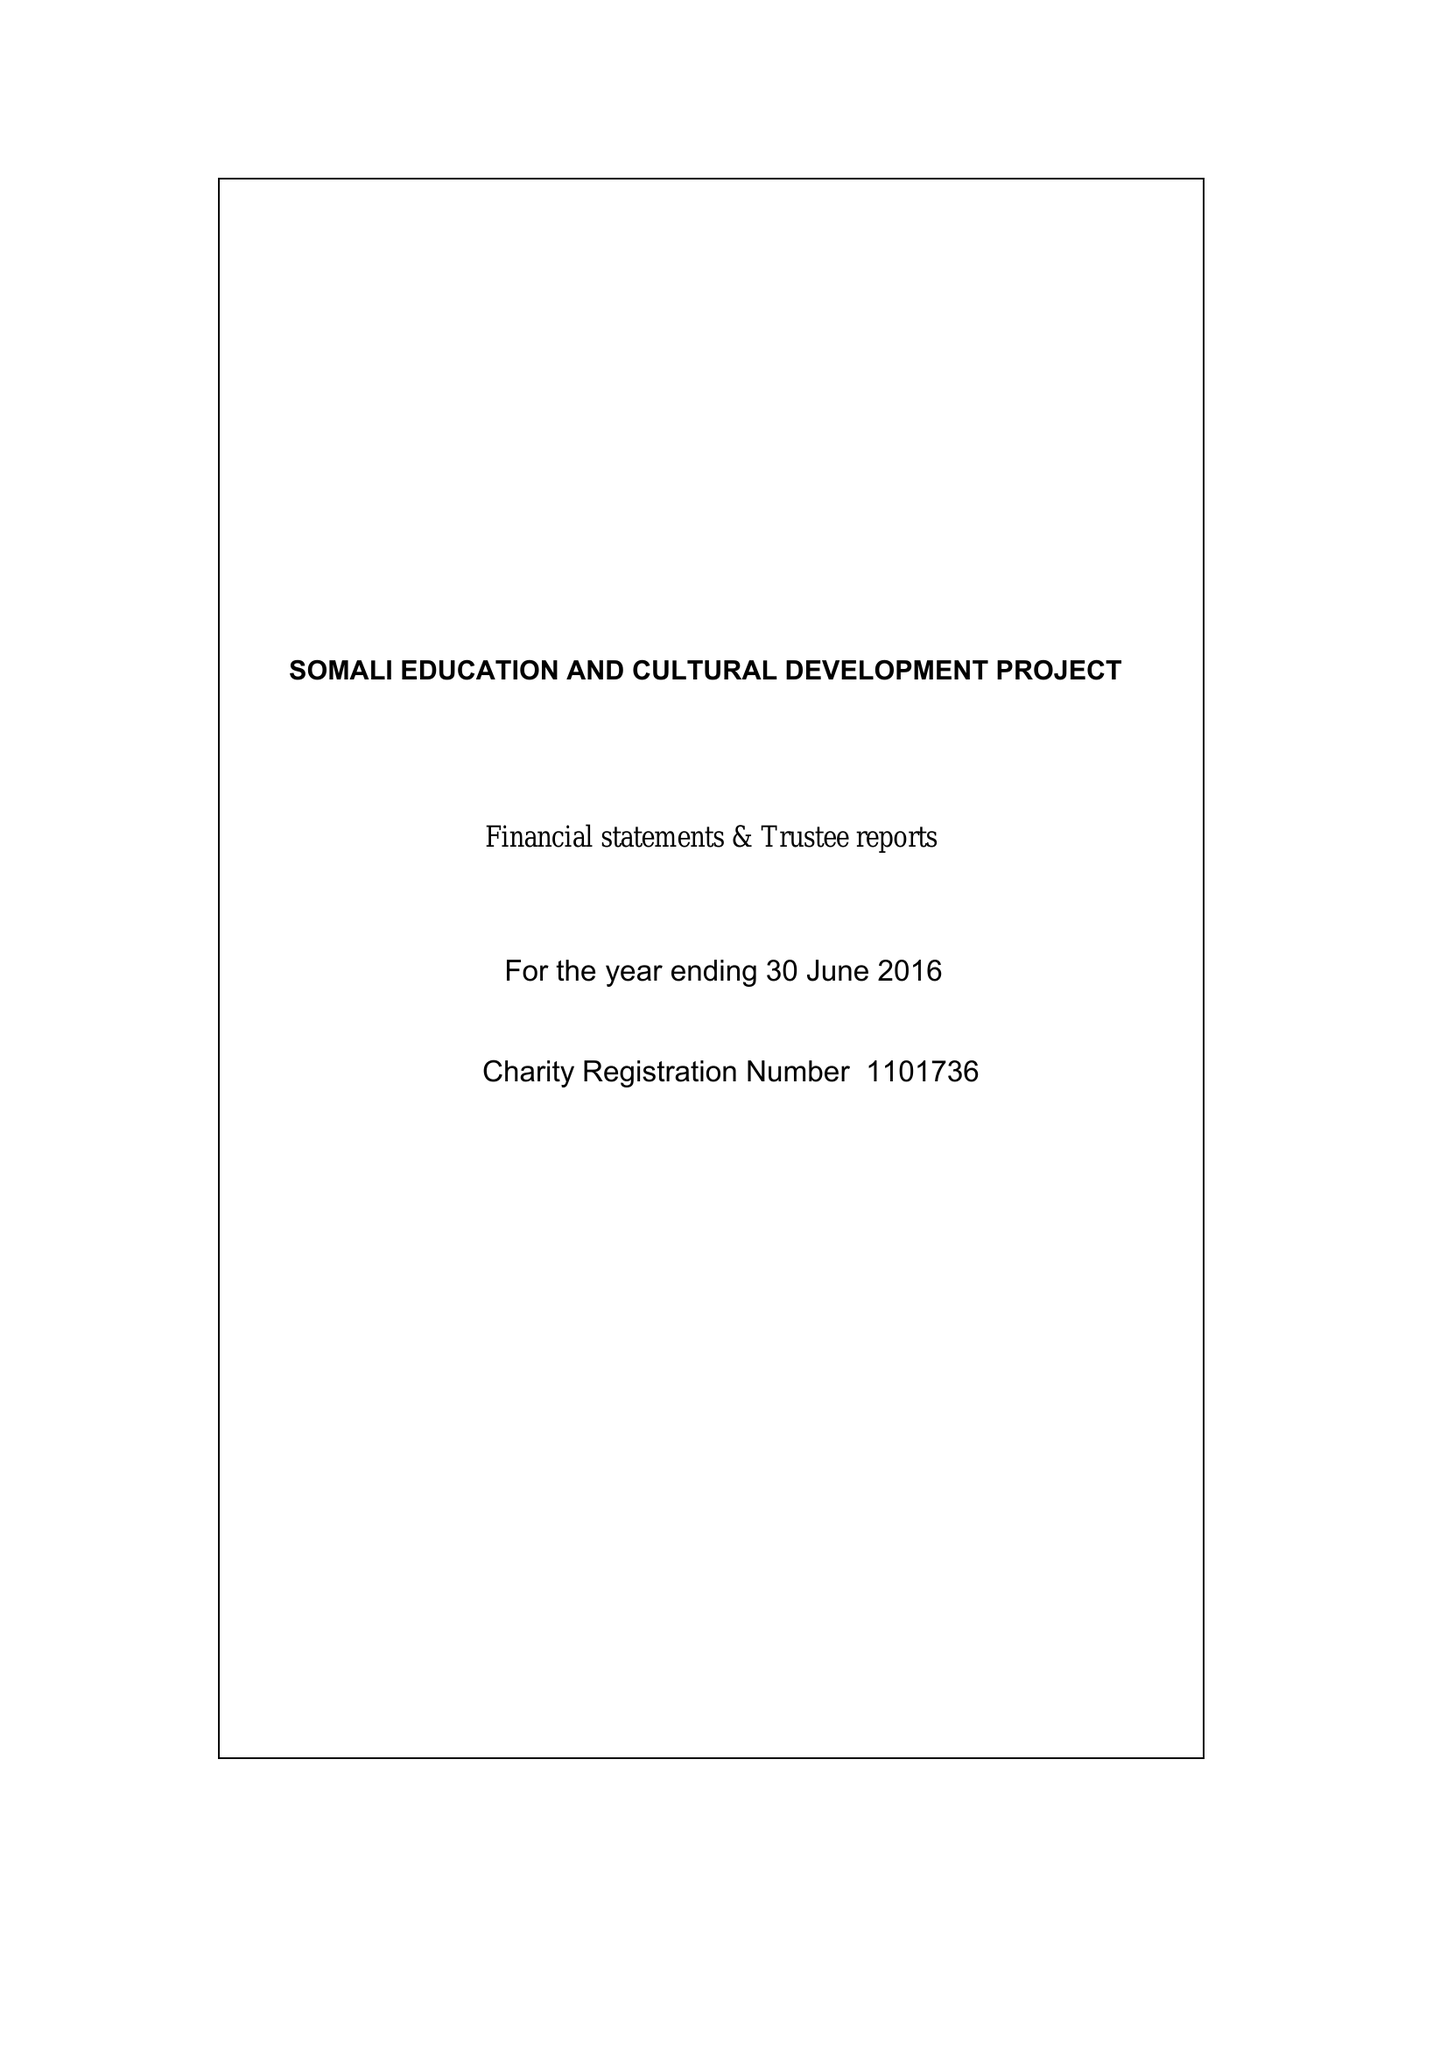What is the value for the address__postcode?
Answer the question using a single word or phrase. SE18 3NT 